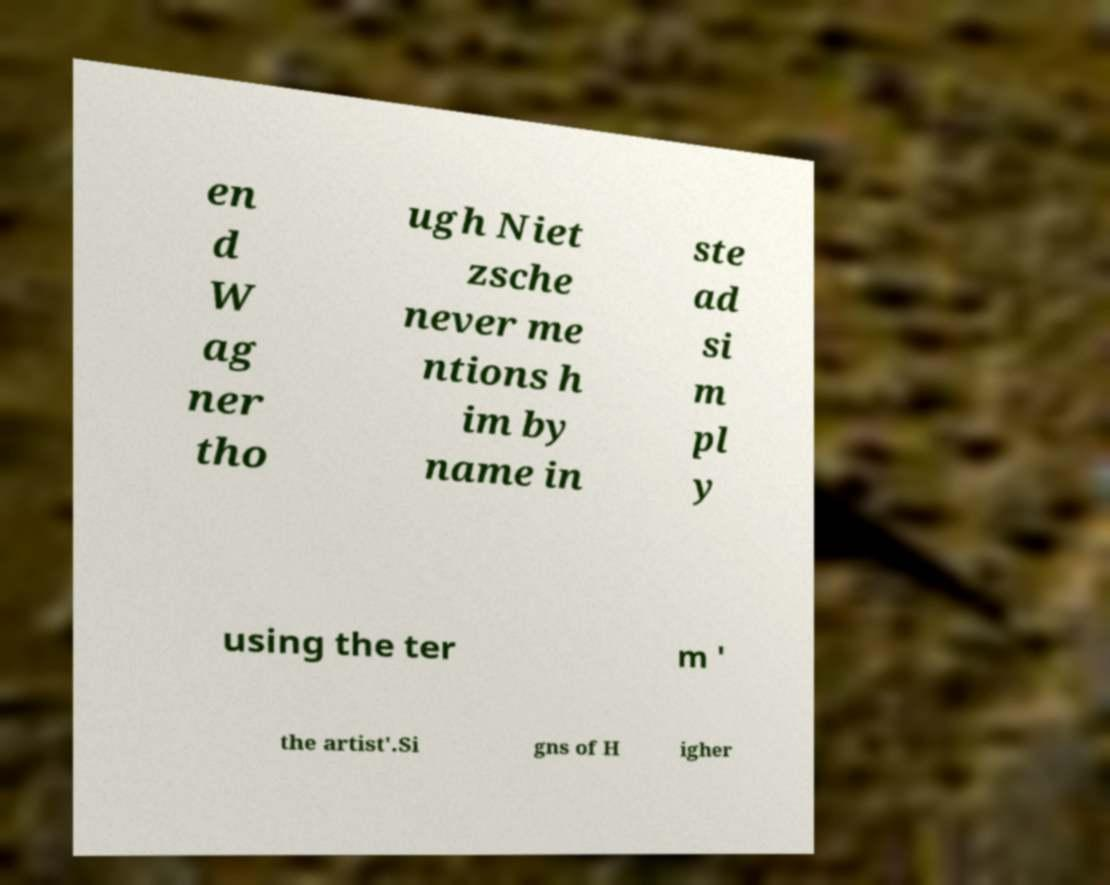I need the written content from this picture converted into text. Can you do that? en d W ag ner tho ugh Niet zsche never me ntions h im by name in ste ad si m pl y using the ter m ' the artist'.Si gns of H igher 